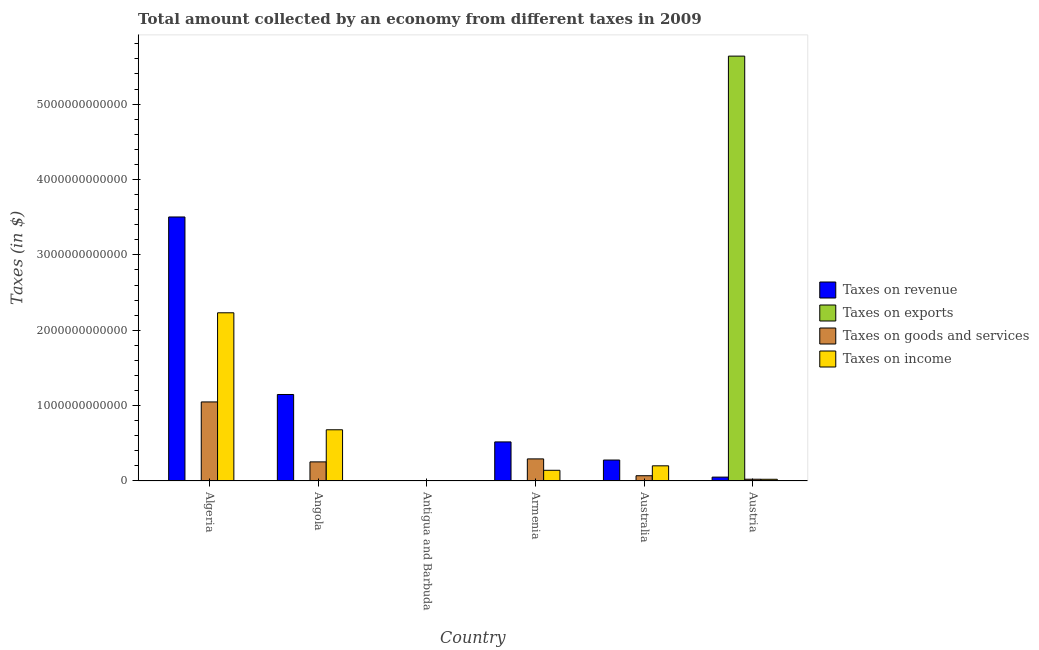How many different coloured bars are there?
Give a very brief answer. 4. How many groups of bars are there?
Offer a terse response. 6. Are the number of bars on each tick of the X-axis equal?
Your response must be concise. Yes. What is the label of the 1st group of bars from the left?
Give a very brief answer. Algeria. What is the amount collected as tax on exports in Algeria?
Your response must be concise. 2.49e+09. Across all countries, what is the maximum amount collected as tax on income?
Ensure brevity in your answer.  2.23e+12. Across all countries, what is the minimum amount collected as tax on goods?
Ensure brevity in your answer.  2.53e+08. In which country was the amount collected as tax on goods maximum?
Offer a very short reply. Algeria. In which country was the amount collected as tax on income minimum?
Your answer should be compact. Antigua and Barbuda. What is the total amount collected as tax on income in the graph?
Give a very brief answer. 3.28e+12. What is the difference between the amount collected as tax on goods in Angola and that in Antigua and Barbuda?
Provide a short and direct response. 2.53e+11. What is the difference between the amount collected as tax on goods in Armenia and the amount collected as tax on exports in Austria?
Your response must be concise. -5.34e+12. What is the average amount collected as tax on income per country?
Your answer should be very brief. 5.46e+11. What is the difference between the amount collected as tax on goods and amount collected as tax on income in Antigua and Barbuda?
Ensure brevity in your answer.  1.55e+08. In how many countries, is the amount collected as tax on exports greater than 4400000000000 $?
Give a very brief answer. 1. What is the ratio of the amount collected as tax on goods in Algeria to that in Australia?
Ensure brevity in your answer.  15. What is the difference between the highest and the second highest amount collected as tax on income?
Make the answer very short. 1.55e+12. What is the difference between the highest and the lowest amount collected as tax on goods?
Provide a short and direct response. 1.05e+12. Is it the case that in every country, the sum of the amount collected as tax on income and amount collected as tax on revenue is greater than the sum of amount collected as tax on exports and amount collected as tax on goods?
Provide a short and direct response. No. What does the 4th bar from the left in Antigua and Barbuda represents?
Provide a short and direct response. Taxes on income. What does the 3rd bar from the right in Algeria represents?
Offer a terse response. Taxes on exports. Is it the case that in every country, the sum of the amount collected as tax on revenue and amount collected as tax on exports is greater than the amount collected as tax on goods?
Make the answer very short. Yes. What is the difference between two consecutive major ticks on the Y-axis?
Your response must be concise. 1.00e+12. Are the values on the major ticks of Y-axis written in scientific E-notation?
Your answer should be compact. No. Does the graph contain any zero values?
Your answer should be compact. No. Does the graph contain grids?
Offer a very short reply. No. How many legend labels are there?
Make the answer very short. 4. How are the legend labels stacked?
Make the answer very short. Vertical. What is the title of the graph?
Give a very brief answer. Total amount collected by an economy from different taxes in 2009. Does "International Monetary Fund" appear as one of the legend labels in the graph?
Your response must be concise. No. What is the label or title of the Y-axis?
Give a very brief answer. Taxes (in $). What is the Taxes (in $) of Taxes on revenue in Algeria?
Your answer should be compact. 3.50e+12. What is the Taxes (in $) in Taxes on exports in Algeria?
Your response must be concise. 2.49e+09. What is the Taxes (in $) in Taxes on goods and services in Algeria?
Provide a short and direct response. 1.05e+12. What is the Taxes (in $) in Taxes on income in Algeria?
Offer a very short reply. 2.23e+12. What is the Taxes (in $) of Taxes on revenue in Angola?
Provide a short and direct response. 1.15e+12. What is the Taxes (in $) in Taxes on exports in Angola?
Ensure brevity in your answer.  7.26e+06. What is the Taxes (in $) of Taxes on goods and services in Angola?
Ensure brevity in your answer.  2.53e+11. What is the Taxes (in $) of Taxes on income in Angola?
Provide a short and direct response. 6.80e+11. What is the Taxes (in $) of Taxes on revenue in Antigua and Barbuda?
Offer a terse response. 5.73e+08. What is the Taxes (in $) in Taxes on exports in Antigua and Barbuda?
Give a very brief answer. 1.30e+07. What is the Taxes (in $) of Taxes on goods and services in Antigua and Barbuda?
Give a very brief answer. 2.53e+08. What is the Taxes (in $) in Taxes on income in Antigua and Barbuda?
Offer a terse response. 9.80e+07. What is the Taxes (in $) of Taxes on revenue in Armenia?
Keep it short and to the point. 5.19e+11. What is the Taxes (in $) in Taxes on exports in Armenia?
Offer a terse response. 2.00e+05. What is the Taxes (in $) of Taxes on goods and services in Armenia?
Offer a terse response. 2.93e+11. What is the Taxes (in $) in Taxes on income in Armenia?
Offer a very short reply. 1.42e+11. What is the Taxes (in $) of Taxes on revenue in Australia?
Keep it short and to the point. 2.78e+11. What is the Taxes (in $) of Taxes on exports in Australia?
Ensure brevity in your answer.  1.27e+07. What is the Taxes (in $) of Taxes on goods and services in Australia?
Keep it short and to the point. 7.00e+1. What is the Taxes (in $) in Taxes on income in Australia?
Offer a terse response. 2.01e+11. What is the Taxes (in $) of Taxes on revenue in Austria?
Your answer should be compact. 5.14e+1. What is the Taxes (in $) in Taxes on exports in Austria?
Offer a terse response. 5.64e+12. What is the Taxes (in $) of Taxes on goods and services in Austria?
Make the answer very short. 2.34e+1. What is the Taxes (in $) of Taxes on income in Austria?
Your answer should be compact. 2.29e+1. Across all countries, what is the maximum Taxes (in $) of Taxes on revenue?
Your answer should be very brief. 3.50e+12. Across all countries, what is the maximum Taxes (in $) of Taxes on exports?
Offer a very short reply. 5.64e+12. Across all countries, what is the maximum Taxes (in $) in Taxes on goods and services?
Make the answer very short. 1.05e+12. Across all countries, what is the maximum Taxes (in $) in Taxes on income?
Offer a very short reply. 2.23e+12. Across all countries, what is the minimum Taxes (in $) in Taxes on revenue?
Keep it short and to the point. 5.73e+08. Across all countries, what is the minimum Taxes (in $) of Taxes on goods and services?
Provide a succinct answer. 2.53e+08. Across all countries, what is the minimum Taxes (in $) in Taxes on income?
Ensure brevity in your answer.  9.80e+07. What is the total Taxes (in $) in Taxes on revenue in the graph?
Keep it short and to the point. 5.50e+12. What is the total Taxes (in $) in Taxes on exports in the graph?
Make the answer very short. 5.64e+12. What is the total Taxes (in $) of Taxes on goods and services in the graph?
Keep it short and to the point. 1.69e+12. What is the total Taxes (in $) of Taxes on income in the graph?
Provide a short and direct response. 3.28e+12. What is the difference between the Taxes (in $) in Taxes on revenue in Algeria and that in Angola?
Ensure brevity in your answer.  2.36e+12. What is the difference between the Taxes (in $) in Taxes on exports in Algeria and that in Angola?
Ensure brevity in your answer.  2.49e+09. What is the difference between the Taxes (in $) in Taxes on goods and services in Algeria and that in Angola?
Provide a short and direct response. 7.95e+11. What is the difference between the Taxes (in $) of Taxes on income in Algeria and that in Angola?
Your response must be concise. 1.55e+12. What is the difference between the Taxes (in $) in Taxes on revenue in Algeria and that in Antigua and Barbuda?
Give a very brief answer. 3.50e+12. What is the difference between the Taxes (in $) in Taxes on exports in Algeria and that in Antigua and Barbuda?
Offer a very short reply. 2.48e+09. What is the difference between the Taxes (in $) of Taxes on goods and services in Algeria and that in Antigua and Barbuda?
Provide a succinct answer. 1.05e+12. What is the difference between the Taxes (in $) in Taxes on income in Algeria and that in Antigua and Barbuda?
Keep it short and to the point. 2.23e+12. What is the difference between the Taxes (in $) in Taxes on revenue in Algeria and that in Armenia?
Your response must be concise. 2.98e+12. What is the difference between the Taxes (in $) of Taxes on exports in Algeria and that in Armenia?
Ensure brevity in your answer.  2.49e+09. What is the difference between the Taxes (in $) of Taxes on goods and services in Algeria and that in Armenia?
Keep it short and to the point. 7.56e+11. What is the difference between the Taxes (in $) in Taxes on income in Algeria and that in Armenia?
Ensure brevity in your answer.  2.09e+12. What is the difference between the Taxes (in $) of Taxes on revenue in Algeria and that in Australia?
Keep it short and to the point. 3.23e+12. What is the difference between the Taxes (in $) in Taxes on exports in Algeria and that in Australia?
Your answer should be compact. 2.48e+09. What is the difference between the Taxes (in $) in Taxes on goods and services in Algeria and that in Australia?
Your answer should be compact. 9.79e+11. What is the difference between the Taxes (in $) of Taxes on income in Algeria and that in Australia?
Your answer should be very brief. 2.03e+12. What is the difference between the Taxes (in $) in Taxes on revenue in Algeria and that in Austria?
Make the answer very short. 3.45e+12. What is the difference between the Taxes (in $) of Taxes on exports in Algeria and that in Austria?
Provide a short and direct response. -5.63e+12. What is the difference between the Taxes (in $) of Taxes on goods and services in Algeria and that in Austria?
Your response must be concise. 1.03e+12. What is the difference between the Taxes (in $) in Taxes on income in Algeria and that in Austria?
Give a very brief answer. 2.21e+12. What is the difference between the Taxes (in $) in Taxes on revenue in Angola and that in Antigua and Barbuda?
Offer a very short reply. 1.15e+12. What is the difference between the Taxes (in $) in Taxes on exports in Angola and that in Antigua and Barbuda?
Your answer should be very brief. -5.74e+06. What is the difference between the Taxes (in $) of Taxes on goods and services in Angola and that in Antigua and Barbuda?
Offer a very short reply. 2.53e+11. What is the difference between the Taxes (in $) in Taxes on income in Angola and that in Antigua and Barbuda?
Your answer should be compact. 6.79e+11. What is the difference between the Taxes (in $) of Taxes on revenue in Angola and that in Armenia?
Ensure brevity in your answer.  6.29e+11. What is the difference between the Taxes (in $) of Taxes on exports in Angola and that in Armenia?
Offer a terse response. 7.06e+06. What is the difference between the Taxes (in $) in Taxes on goods and services in Angola and that in Armenia?
Provide a succinct answer. -3.96e+1. What is the difference between the Taxes (in $) of Taxes on income in Angola and that in Armenia?
Keep it short and to the point. 5.38e+11. What is the difference between the Taxes (in $) of Taxes on revenue in Angola and that in Australia?
Your answer should be compact. 8.70e+11. What is the difference between the Taxes (in $) of Taxes on exports in Angola and that in Australia?
Give a very brief answer. -5.48e+06. What is the difference between the Taxes (in $) of Taxes on goods and services in Angola and that in Australia?
Keep it short and to the point. 1.84e+11. What is the difference between the Taxes (in $) of Taxes on income in Angola and that in Australia?
Provide a short and direct response. 4.78e+11. What is the difference between the Taxes (in $) of Taxes on revenue in Angola and that in Austria?
Your response must be concise. 1.10e+12. What is the difference between the Taxes (in $) of Taxes on exports in Angola and that in Austria?
Ensure brevity in your answer.  -5.64e+12. What is the difference between the Taxes (in $) in Taxes on goods and services in Angola and that in Austria?
Your answer should be very brief. 2.30e+11. What is the difference between the Taxes (in $) of Taxes on income in Angola and that in Austria?
Provide a short and direct response. 6.57e+11. What is the difference between the Taxes (in $) of Taxes on revenue in Antigua and Barbuda and that in Armenia?
Offer a very short reply. -5.18e+11. What is the difference between the Taxes (in $) of Taxes on exports in Antigua and Barbuda and that in Armenia?
Keep it short and to the point. 1.28e+07. What is the difference between the Taxes (in $) of Taxes on goods and services in Antigua and Barbuda and that in Armenia?
Ensure brevity in your answer.  -2.93e+11. What is the difference between the Taxes (in $) in Taxes on income in Antigua and Barbuda and that in Armenia?
Keep it short and to the point. -1.42e+11. What is the difference between the Taxes (in $) of Taxes on revenue in Antigua and Barbuda and that in Australia?
Offer a terse response. -2.77e+11. What is the difference between the Taxes (in $) of Taxes on exports in Antigua and Barbuda and that in Australia?
Provide a succinct answer. 2.55e+05. What is the difference between the Taxes (in $) of Taxes on goods and services in Antigua and Barbuda and that in Australia?
Give a very brief answer. -6.97e+1. What is the difference between the Taxes (in $) of Taxes on income in Antigua and Barbuda and that in Australia?
Provide a short and direct response. -2.01e+11. What is the difference between the Taxes (in $) in Taxes on revenue in Antigua and Barbuda and that in Austria?
Offer a terse response. -5.08e+1. What is the difference between the Taxes (in $) in Taxes on exports in Antigua and Barbuda and that in Austria?
Provide a succinct answer. -5.64e+12. What is the difference between the Taxes (in $) in Taxes on goods and services in Antigua and Barbuda and that in Austria?
Your answer should be compact. -2.32e+1. What is the difference between the Taxes (in $) of Taxes on income in Antigua and Barbuda and that in Austria?
Ensure brevity in your answer.  -2.28e+1. What is the difference between the Taxes (in $) of Taxes on revenue in Armenia and that in Australia?
Keep it short and to the point. 2.41e+11. What is the difference between the Taxes (in $) in Taxes on exports in Armenia and that in Australia?
Give a very brief answer. -1.25e+07. What is the difference between the Taxes (in $) of Taxes on goods and services in Armenia and that in Australia?
Your answer should be very brief. 2.23e+11. What is the difference between the Taxes (in $) in Taxes on income in Armenia and that in Australia?
Offer a very short reply. -5.93e+1. What is the difference between the Taxes (in $) of Taxes on revenue in Armenia and that in Austria?
Offer a very short reply. 4.67e+11. What is the difference between the Taxes (in $) in Taxes on exports in Armenia and that in Austria?
Give a very brief answer. -5.64e+12. What is the difference between the Taxes (in $) of Taxes on goods and services in Armenia and that in Austria?
Give a very brief answer. 2.70e+11. What is the difference between the Taxes (in $) of Taxes on income in Armenia and that in Austria?
Your answer should be compact. 1.19e+11. What is the difference between the Taxes (in $) of Taxes on revenue in Australia and that in Austria?
Your response must be concise. 2.27e+11. What is the difference between the Taxes (in $) in Taxes on exports in Australia and that in Austria?
Your answer should be compact. -5.64e+12. What is the difference between the Taxes (in $) in Taxes on goods and services in Australia and that in Austria?
Provide a short and direct response. 4.65e+1. What is the difference between the Taxes (in $) of Taxes on income in Australia and that in Austria?
Offer a terse response. 1.78e+11. What is the difference between the Taxes (in $) of Taxes on revenue in Algeria and the Taxes (in $) of Taxes on exports in Angola?
Provide a succinct answer. 3.50e+12. What is the difference between the Taxes (in $) in Taxes on revenue in Algeria and the Taxes (in $) in Taxes on goods and services in Angola?
Provide a short and direct response. 3.25e+12. What is the difference between the Taxes (in $) of Taxes on revenue in Algeria and the Taxes (in $) of Taxes on income in Angola?
Your response must be concise. 2.82e+12. What is the difference between the Taxes (in $) of Taxes on exports in Algeria and the Taxes (in $) of Taxes on goods and services in Angola?
Offer a terse response. -2.51e+11. What is the difference between the Taxes (in $) in Taxes on exports in Algeria and the Taxes (in $) in Taxes on income in Angola?
Your answer should be compact. -6.77e+11. What is the difference between the Taxes (in $) in Taxes on goods and services in Algeria and the Taxes (in $) in Taxes on income in Angola?
Your answer should be very brief. 3.69e+11. What is the difference between the Taxes (in $) in Taxes on revenue in Algeria and the Taxes (in $) in Taxes on exports in Antigua and Barbuda?
Make the answer very short. 3.50e+12. What is the difference between the Taxes (in $) in Taxes on revenue in Algeria and the Taxes (in $) in Taxes on goods and services in Antigua and Barbuda?
Offer a terse response. 3.50e+12. What is the difference between the Taxes (in $) of Taxes on revenue in Algeria and the Taxes (in $) of Taxes on income in Antigua and Barbuda?
Make the answer very short. 3.50e+12. What is the difference between the Taxes (in $) of Taxes on exports in Algeria and the Taxes (in $) of Taxes on goods and services in Antigua and Barbuda?
Provide a succinct answer. 2.24e+09. What is the difference between the Taxes (in $) in Taxes on exports in Algeria and the Taxes (in $) in Taxes on income in Antigua and Barbuda?
Offer a very short reply. 2.40e+09. What is the difference between the Taxes (in $) of Taxes on goods and services in Algeria and the Taxes (in $) of Taxes on income in Antigua and Barbuda?
Give a very brief answer. 1.05e+12. What is the difference between the Taxes (in $) in Taxes on revenue in Algeria and the Taxes (in $) in Taxes on exports in Armenia?
Your response must be concise. 3.50e+12. What is the difference between the Taxes (in $) in Taxes on revenue in Algeria and the Taxes (in $) in Taxes on goods and services in Armenia?
Provide a succinct answer. 3.21e+12. What is the difference between the Taxes (in $) in Taxes on revenue in Algeria and the Taxes (in $) in Taxes on income in Armenia?
Provide a short and direct response. 3.36e+12. What is the difference between the Taxes (in $) in Taxes on exports in Algeria and the Taxes (in $) in Taxes on goods and services in Armenia?
Your response must be concise. -2.91e+11. What is the difference between the Taxes (in $) in Taxes on exports in Algeria and the Taxes (in $) in Taxes on income in Armenia?
Offer a terse response. -1.40e+11. What is the difference between the Taxes (in $) in Taxes on goods and services in Algeria and the Taxes (in $) in Taxes on income in Armenia?
Give a very brief answer. 9.07e+11. What is the difference between the Taxes (in $) of Taxes on revenue in Algeria and the Taxes (in $) of Taxes on exports in Australia?
Your answer should be compact. 3.50e+12. What is the difference between the Taxes (in $) in Taxes on revenue in Algeria and the Taxes (in $) in Taxes on goods and services in Australia?
Your answer should be very brief. 3.43e+12. What is the difference between the Taxes (in $) of Taxes on revenue in Algeria and the Taxes (in $) of Taxes on income in Australia?
Give a very brief answer. 3.30e+12. What is the difference between the Taxes (in $) of Taxes on exports in Algeria and the Taxes (in $) of Taxes on goods and services in Australia?
Ensure brevity in your answer.  -6.75e+1. What is the difference between the Taxes (in $) of Taxes on exports in Algeria and the Taxes (in $) of Taxes on income in Australia?
Provide a succinct answer. -1.99e+11. What is the difference between the Taxes (in $) in Taxes on goods and services in Algeria and the Taxes (in $) in Taxes on income in Australia?
Offer a terse response. 8.48e+11. What is the difference between the Taxes (in $) of Taxes on revenue in Algeria and the Taxes (in $) of Taxes on exports in Austria?
Ensure brevity in your answer.  -2.13e+12. What is the difference between the Taxes (in $) in Taxes on revenue in Algeria and the Taxes (in $) in Taxes on goods and services in Austria?
Give a very brief answer. 3.48e+12. What is the difference between the Taxes (in $) of Taxes on revenue in Algeria and the Taxes (in $) of Taxes on income in Austria?
Ensure brevity in your answer.  3.48e+12. What is the difference between the Taxes (in $) of Taxes on exports in Algeria and the Taxes (in $) of Taxes on goods and services in Austria?
Your response must be concise. -2.09e+1. What is the difference between the Taxes (in $) of Taxes on exports in Algeria and the Taxes (in $) of Taxes on income in Austria?
Ensure brevity in your answer.  -2.04e+1. What is the difference between the Taxes (in $) of Taxes on goods and services in Algeria and the Taxes (in $) of Taxes on income in Austria?
Provide a succinct answer. 1.03e+12. What is the difference between the Taxes (in $) in Taxes on revenue in Angola and the Taxes (in $) in Taxes on exports in Antigua and Barbuda?
Your answer should be compact. 1.15e+12. What is the difference between the Taxes (in $) of Taxes on revenue in Angola and the Taxes (in $) of Taxes on goods and services in Antigua and Barbuda?
Make the answer very short. 1.15e+12. What is the difference between the Taxes (in $) of Taxes on revenue in Angola and the Taxes (in $) of Taxes on income in Antigua and Barbuda?
Make the answer very short. 1.15e+12. What is the difference between the Taxes (in $) of Taxes on exports in Angola and the Taxes (in $) of Taxes on goods and services in Antigua and Barbuda?
Provide a short and direct response. -2.45e+08. What is the difference between the Taxes (in $) of Taxes on exports in Angola and the Taxes (in $) of Taxes on income in Antigua and Barbuda?
Ensure brevity in your answer.  -9.07e+07. What is the difference between the Taxes (in $) of Taxes on goods and services in Angola and the Taxes (in $) of Taxes on income in Antigua and Barbuda?
Offer a terse response. 2.53e+11. What is the difference between the Taxes (in $) of Taxes on revenue in Angola and the Taxes (in $) of Taxes on exports in Armenia?
Make the answer very short. 1.15e+12. What is the difference between the Taxes (in $) in Taxes on revenue in Angola and the Taxes (in $) in Taxes on goods and services in Armenia?
Provide a short and direct response. 8.55e+11. What is the difference between the Taxes (in $) in Taxes on revenue in Angola and the Taxes (in $) in Taxes on income in Armenia?
Provide a short and direct response. 1.01e+12. What is the difference between the Taxes (in $) of Taxes on exports in Angola and the Taxes (in $) of Taxes on goods and services in Armenia?
Provide a short and direct response. -2.93e+11. What is the difference between the Taxes (in $) in Taxes on exports in Angola and the Taxes (in $) in Taxes on income in Armenia?
Your response must be concise. -1.42e+11. What is the difference between the Taxes (in $) of Taxes on goods and services in Angola and the Taxes (in $) of Taxes on income in Armenia?
Ensure brevity in your answer.  1.11e+11. What is the difference between the Taxes (in $) of Taxes on revenue in Angola and the Taxes (in $) of Taxes on exports in Australia?
Your response must be concise. 1.15e+12. What is the difference between the Taxes (in $) in Taxes on revenue in Angola and the Taxes (in $) in Taxes on goods and services in Australia?
Your answer should be very brief. 1.08e+12. What is the difference between the Taxes (in $) in Taxes on revenue in Angola and the Taxes (in $) in Taxes on income in Australia?
Your response must be concise. 9.46e+11. What is the difference between the Taxes (in $) in Taxes on exports in Angola and the Taxes (in $) in Taxes on goods and services in Australia?
Provide a succinct answer. -6.99e+1. What is the difference between the Taxes (in $) in Taxes on exports in Angola and the Taxes (in $) in Taxes on income in Australia?
Your response must be concise. -2.01e+11. What is the difference between the Taxes (in $) of Taxes on goods and services in Angola and the Taxes (in $) of Taxes on income in Australia?
Ensure brevity in your answer.  5.21e+1. What is the difference between the Taxes (in $) of Taxes on revenue in Angola and the Taxes (in $) of Taxes on exports in Austria?
Provide a short and direct response. -4.49e+12. What is the difference between the Taxes (in $) in Taxes on revenue in Angola and the Taxes (in $) in Taxes on goods and services in Austria?
Your answer should be compact. 1.12e+12. What is the difference between the Taxes (in $) of Taxes on revenue in Angola and the Taxes (in $) of Taxes on income in Austria?
Offer a terse response. 1.12e+12. What is the difference between the Taxes (in $) of Taxes on exports in Angola and the Taxes (in $) of Taxes on goods and services in Austria?
Give a very brief answer. -2.34e+1. What is the difference between the Taxes (in $) in Taxes on exports in Angola and the Taxes (in $) in Taxes on income in Austria?
Your response must be concise. -2.29e+1. What is the difference between the Taxes (in $) in Taxes on goods and services in Angola and the Taxes (in $) in Taxes on income in Austria?
Ensure brevity in your answer.  2.31e+11. What is the difference between the Taxes (in $) of Taxes on revenue in Antigua and Barbuda and the Taxes (in $) of Taxes on exports in Armenia?
Give a very brief answer. 5.73e+08. What is the difference between the Taxes (in $) in Taxes on revenue in Antigua and Barbuda and the Taxes (in $) in Taxes on goods and services in Armenia?
Offer a terse response. -2.93e+11. What is the difference between the Taxes (in $) of Taxes on revenue in Antigua and Barbuda and the Taxes (in $) of Taxes on income in Armenia?
Provide a short and direct response. -1.41e+11. What is the difference between the Taxes (in $) in Taxes on exports in Antigua and Barbuda and the Taxes (in $) in Taxes on goods and services in Armenia?
Offer a terse response. -2.93e+11. What is the difference between the Taxes (in $) in Taxes on exports in Antigua and Barbuda and the Taxes (in $) in Taxes on income in Armenia?
Offer a very short reply. -1.42e+11. What is the difference between the Taxes (in $) of Taxes on goods and services in Antigua and Barbuda and the Taxes (in $) of Taxes on income in Armenia?
Keep it short and to the point. -1.42e+11. What is the difference between the Taxes (in $) of Taxes on revenue in Antigua and Barbuda and the Taxes (in $) of Taxes on exports in Australia?
Provide a succinct answer. 5.61e+08. What is the difference between the Taxes (in $) in Taxes on revenue in Antigua and Barbuda and the Taxes (in $) in Taxes on goods and services in Australia?
Your answer should be very brief. -6.94e+1. What is the difference between the Taxes (in $) in Taxes on revenue in Antigua and Barbuda and the Taxes (in $) in Taxes on income in Australia?
Your answer should be very brief. -2.01e+11. What is the difference between the Taxes (in $) of Taxes on exports in Antigua and Barbuda and the Taxes (in $) of Taxes on goods and services in Australia?
Your response must be concise. -6.99e+1. What is the difference between the Taxes (in $) in Taxes on exports in Antigua and Barbuda and the Taxes (in $) in Taxes on income in Australia?
Ensure brevity in your answer.  -2.01e+11. What is the difference between the Taxes (in $) in Taxes on goods and services in Antigua and Barbuda and the Taxes (in $) in Taxes on income in Australia?
Provide a succinct answer. -2.01e+11. What is the difference between the Taxes (in $) in Taxes on revenue in Antigua and Barbuda and the Taxes (in $) in Taxes on exports in Austria?
Your answer should be compact. -5.64e+12. What is the difference between the Taxes (in $) of Taxes on revenue in Antigua and Barbuda and the Taxes (in $) of Taxes on goods and services in Austria?
Your answer should be very brief. -2.28e+1. What is the difference between the Taxes (in $) of Taxes on revenue in Antigua and Barbuda and the Taxes (in $) of Taxes on income in Austria?
Give a very brief answer. -2.23e+1. What is the difference between the Taxes (in $) in Taxes on exports in Antigua and Barbuda and the Taxes (in $) in Taxes on goods and services in Austria?
Your response must be concise. -2.34e+1. What is the difference between the Taxes (in $) in Taxes on exports in Antigua and Barbuda and the Taxes (in $) in Taxes on income in Austria?
Your answer should be compact. -2.29e+1. What is the difference between the Taxes (in $) of Taxes on goods and services in Antigua and Barbuda and the Taxes (in $) of Taxes on income in Austria?
Make the answer very short. -2.27e+1. What is the difference between the Taxes (in $) of Taxes on revenue in Armenia and the Taxes (in $) of Taxes on exports in Australia?
Keep it short and to the point. 5.19e+11. What is the difference between the Taxes (in $) in Taxes on revenue in Armenia and the Taxes (in $) in Taxes on goods and services in Australia?
Give a very brief answer. 4.49e+11. What is the difference between the Taxes (in $) of Taxes on revenue in Armenia and the Taxes (in $) of Taxes on income in Australia?
Your answer should be very brief. 3.17e+11. What is the difference between the Taxes (in $) in Taxes on exports in Armenia and the Taxes (in $) in Taxes on goods and services in Australia?
Give a very brief answer. -7.00e+1. What is the difference between the Taxes (in $) in Taxes on exports in Armenia and the Taxes (in $) in Taxes on income in Australia?
Give a very brief answer. -2.01e+11. What is the difference between the Taxes (in $) in Taxes on goods and services in Armenia and the Taxes (in $) in Taxes on income in Australia?
Offer a very short reply. 9.18e+1. What is the difference between the Taxes (in $) in Taxes on revenue in Armenia and the Taxes (in $) in Taxes on exports in Austria?
Keep it short and to the point. -5.12e+12. What is the difference between the Taxes (in $) of Taxes on revenue in Armenia and the Taxes (in $) of Taxes on goods and services in Austria?
Provide a short and direct response. 4.95e+11. What is the difference between the Taxes (in $) of Taxes on revenue in Armenia and the Taxes (in $) of Taxes on income in Austria?
Ensure brevity in your answer.  4.96e+11. What is the difference between the Taxes (in $) of Taxes on exports in Armenia and the Taxes (in $) of Taxes on goods and services in Austria?
Your answer should be compact. -2.34e+1. What is the difference between the Taxes (in $) in Taxes on exports in Armenia and the Taxes (in $) in Taxes on income in Austria?
Provide a succinct answer. -2.29e+1. What is the difference between the Taxes (in $) in Taxes on goods and services in Armenia and the Taxes (in $) in Taxes on income in Austria?
Ensure brevity in your answer.  2.70e+11. What is the difference between the Taxes (in $) in Taxes on revenue in Australia and the Taxes (in $) in Taxes on exports in Austria?
Your answer should be compact. -5.36e+12. What is the difference between the Taxes (in $) in Taxes on revenue in Australia and the Taxes (in $) in Taxes on goods and services in Austria?
Provide a short and direct response. 2.55e+11. What is the difference between the Taxes (in $) in Taxes on revenue in Australia and the Taxes (in $) in Taxes on income in Austria?
Offer a very short reply. 2.55e+11. What is the difference between the Taxes (in $) of Taxes on exports in Australia and the Taxes (in $) of Taxes on goods and services in Austria?
Your answer should be very brief. -2.34e+1. What is the difference between the Taxes (in $) of Taxes on exports in Australia and the Taxes (in $) of Taxes on income in Austria?
Your response must be concise. -2.29e+1. What is the difference between the Taxes (in $) of Taxes on goods and services in Australia and the Taxes (in $) of Taxes on income in Austria?
Ensure brevity in your answer.  4.70e+1. What is the average Taxes (in $) in Taxes on revenue per country?
Your response must be concise. 9.17e+11. What is the average Taxes (in $) of Taxes on exports per country?
Offer a terse response. 9.40e+11. What is the average Taxes (in $) in Taxes on goods and services per country?
Keep it short and to the point. 2.82e+11. What is the average Taxes (in $) of Taxes on income per country?
Your response must be concise. 5.46e+11. What is the difference between the Taxes (in $) in Taxes on revenue and Taxes (in $) in Taxes on exports in Algeria?
Provide a short and direct response. 3.50e+12. What is the difference between the Taxes (in $) in Taxes on revenue and Taxes (in $) in Taxes on goods and services in Algeria?
Give a very brief answer. 2.45e+12. What is the difference between the Taxes (in $) of Taxes on revenue and Taxes (in $) of Taxes on income in Algeria?
Provide a short and direct response. 1.27e+12. What is the difference between the Taxes (in $) of Taxes on exports and Taxes (in $) of Taxes on goods and services in Algeria?
Ensure brevity in your answer.  -1.05e+12. What is the difference between the Taxes (in $) in Taxes on exports and Taxes (in $) in Taxes on income in Algeria?
Provide a short and direct response. -2.23e+12. What is the difference between the Taxes (in $) of Taxes on goods and services and Taxes (in $) of Taxes on income in Algeria?
Your response must be concise. -1.18e+12. What is the difference between the Taxes (in $) of Taxes on revenue and Taxes (in $) of Taxes on exports in Angola?
Make the answer very short. 1.15e+12. What is the difference between the Taxes (in $) of Taxes on revenue and Taxes (in $) of Taxes on goods and services in Angola?
Offer a terse response. 8.94e+11. What is the difference between the Taxes (in $) of Taxes on revenue and Taxes (in $) of Taxes on income in Angola?
Offer a very short reply. 4.68e+11. What is the difference between the Taxes (in $) in Taxes on exports and Taxes (in $) in Taxes on goods and services in Angola?
Your response must be concise. -2.53e+11. What is the difference between the Taxes (in $) of Taxes on exports and Taxes (in $) of Taxes on income in Angola?
Offer a very short reply. -6.80e+11. What is the difference between the Taxes (in $) of Taxes on goods and services and Taxes (in $) of Taxes on income in Angola?
Provide a succinct answer. -4.26e+11. What is the difference between the Taxes (in $) in Taxes on revenue and Taxes (in $) in Taxes on exports in Antigua and Barbuda?
Give a very brief answer. 5.60e+08. What is the difference between the Taxes (in $) in Taxes on revenue and Taxes (in $) in Taxes on goods and services in Antigua and Barbuda?
Provide a succinct answer. 3.21e+08. What is the difference between the Taxes (in $) in Taxes on revenue and Taxes (in $) in Taxes on income in Antigua and Barbuda?
Give a very brief answer. 4.75e+08. What is the difference between the Taxes (in $) in Taxes on exports and Taxes (in $) in Taxes on goods and services in Antigua and Barbuda?
Provide a succinct answer. -2.40e+08. What is the difference between the Taxes (in $) in Taxes on exports and Taxes (in $) in Taxes on income in Antigua and Barbuda?
Your answer should be very brief. -8.50e+07. What is the difference between the Taxes (in $) in Taxes on goods and services and Taxes (in $) in Taxes on income in Antigua and Barbuda?
Your response must be concise. 1.55e+08. What is the difference between the Taxes (in $) in Taxes on revenue and Taxes (in $) in Taxes on exports in Armenia?
Offer a terse response. 5.19e+11. What is the difference between the Taxes (in $) of Taxes on revenue and Taxes (in $) of Taxes on goods and services in Armenia?
Provide a short and direct response. 2.25e+11. What is the difference between the Taxes (in $) in Taxes on revenue and Taxes (in $) in Taxes on income in Armenia?
Your response must be concise. 3.77e+11. What is the difference between the Taxes (in $) of Taxes on exports and Taxes (in $) of Taxes on goods and services in Armenia?
Make the answer very short. -2.93e+11. What is the difference between the Taxes (in $) in Taxes on exports and Taxes (in $) in Taxes on income in Armenia?
Your answer should be very brief. -1.42e+11. What is the difference between the Taxes (in $) in Taxes on goods and services and Taxes (in $) in Taxes on income in Armenia?
Keep it short and to the point. 1.51e+11. What is the difference between the Taxes (in $) in Taxes on revenue and Taxes (in $) in Taxes on exports in Australia?
Make the answer very short. 2.78e+11. What is the difference between the Taxes (in $) of Taxes on revenue and Taxes (in $) of Taxes on goods and services in Australia?
Offer a terse response. 2.08e+11. What is the difference between the Taxes (in $) in Taxes on revenue and Taxes (in $) in Taxes on income in Australia?
Your answer should be very brief. 7.66e+1. What is the difference between the Taxes (in $) of Taxes on exports and Taxes (in $) of Taxes on goods and services in Australia?
Offer a very short reply. -6.99e+1. What is the difference between the Taxes (in $) in Taxes on exports and Taxes (in $) in Taxes on income in Australia?
Ensure brevity in your answer.  -2.01e+11. What is the difference between the Taxes (in $) in Taxes on goods and services and Taxes (in $) in Taxes on income in Australia?
Your response must be concise. -1.31e+11. What is the difference between the Taxes (in $) in Taxes on revenue and Taxes (in $) in Taxes on exports in Austria?
Your answer should be compact. -5.59e+12. What is the difference between the Taxes (in $) of Taxes on revenue and Taxes (in $) of Taxes on goods and services in Austria?
Provide a succinct answer. 2.79e+1. What is the difference between the Taxes (in $) of Taxes on revenue and Taxes (in $) of Taxes on income in Austria?
Keep it short and to the point. 2.84e+1. What is the difference between the Taxes (in $) of Taxes on exports and Taxes (in $) of Taxes on goods and services in Austria?
Provide a succinct answer. 5.61e+12. What is the difference between the Taxes (in $) in Taxes on exports and Taxes (in $) in Taxes on income in Austria?
Your answer should be compact. 5.61e+12. What is the difference between the Taxes (in $) in Taxes on goods and services and Taxes (in $) in Taxes on income in Austria?
Offer a terse response. 5.01e+08. What is the ratio of the Taxes (in $) of Taxes on revenue in Algeria to that in Angola?
Your answer should be very brief. 3.05. What is the ratio of the Taxes (in $) in Taxes on exports in Algeria to that in Angola?
Your answer should be very brief. 343.47. What is the ratio of the Taxes (in $) in Taxes on goods and services in Algeria to that in Angola?
Provide a short and direct response. 4.14. What is the ratio of the Taxes (in $) of Taxes on income in Algeria to that in Angola?
Offer a very short reply. 3.28. What is the ratio of the Taxes (in $) of Taxes on revenue in Algeria to that in Antigua and Barbuda?
Your answer should be compact. 6109.27. What is the ratio of the Taxes (in $) in Taxes on exports in Algeria to that in Antigua and Barbuda?
Provide a succinct answer. 191.82. What is the ratio of the Taxes (in $) of Taxes on goods and services in Algeria to that in Antigua and Barbuda?
Give a very brief answer. 4152.56. What is the ratio of the Taxes (in $) of Taxes on income in Algeria to that in Antigua and Barbuda?
Your answer should be very brief. 2.28e+04. What is the ratio of the Taxes (in $) in Taxes on revenue in Algeria to that in Armenia?
Make the answer very short. 6.76. What is the ratio of the Taxes (in $) of Taxes on exports in Algeria to that in Armenia?
Provide a short and direct response. 1.25e+04. What is the ratio of the Taxes (in $) of Taxes on goods and services in Algeria to that in Armenia?
Give a very brief answer. 3.58. What is the ratio of the Taxes (in $) of Taxes on income in Algeria to that in Armenia?
Your response must be concise. 15.71. What is the ratio of the Taxes (in $) of Taxes on revenue in Algeria to that in Australia?
Give a very brief answer. 12.6. What is the ratio of the Taxes (in $) in Taxes on exports in Algeria to that in Australia?
Offer a terse response. 195.66. What is the ratio of the Taxes (in $) in Taxes on goods and services in Algeria to that in Australia?
Provide a succinct answer. 15. What is the ratio of the Taxes (in $) of Taxes on income in Algeria to that in Australia?
Keep it short and to the point. 11.08. What is the ratio of the Taxes (in $) in Taxes on revenue in Algeria to that in Austria?
Provide a short and direct response. 68.21. What is the ratio of the Taxes (in $) in Taxes on exports in Algeria to that in Austria?
Give a very brief answer. 0. What is the ratio of the Taxes (in $) in Taxes on goods and services in Algeria to that in Austria?
Give a very brief answer. 44.79. What is the ratio of the Taxes (in $) of Taxes on income in Algeria to that in Austria?
Your response must be concise. 97.38. What is the ratio of the Taxes (in $) in Taxes on revenue in Angola to that in Antigua and Barbuda?
Give a very brief answer. 2001.72. What is the ratio of the Taxes (in $) in Taxes on exports in Angola to that in Antigua and Barbuda?
Give a very brief answer. 0.56. What is the ratio of the Taxes (in $) of Taxes on goods and services in Angola to that in Antigua and Barbuda?
Offer a terse response. 1003.56. What is the ratio of the Taxes (in $) of Taxes on income in Angola to that in Antigua and Barbuda?
Make the answer very short. 6934.55. What is the ratio of the Taxes (in $) of Taxes on revenue in Angola to that in Armenia?
Provide a short and direct response. 2.21. What is the ratio of the Taxes (in $) of Taxes on exports in Angola to that in Armenia?
Provide a short and direct response. 36.3. What is the ratio of the Taxes (in $) in Taxes on goods and services in Angola to that in Armenia?
Offer a terse response. 0.86. What is the ratio of the Taxes (in $) in Taxes on income in Angola to that in Armenia?
Provide a succinct answer. 4.79. What is the ratio of the Taxes (in $) in Taxes on revenue in Angola to that in Australia?
Provide a short and direct response. 4.13. What is the ratio of the Taxes (in $) of Taxes on exports in Angola to that in Australia?
Give a very brief answer. 0.57. What is the ratio of the Taxes (in $) of Taxes on goods and services in Angola to that in Australia?
Your answer should be very brief. 3.62. What is the ratio of the Taxes (in $) of Taxes on income in Angola to that in Australia?
Provide a succinct answer. 3.37. What is the ratio of the Taxes (in $) in Taxes on revenue in Angola to that in Austria?
Keep it short and to the point. 22.35. What is the ratio of the Taxes (in $) of Taxes on goods and services in Angola to that in Austria?
Offer a very short reply. 10.82. What is the ratio of the Taxes (in $) of Taxes on income in Angola to that in Austria?
Offer a very short reply. 29.65. What is the ratio of the Taxes (in $) of Taxes on revenue in Antigua and Barbuda to that in Armenia?
Ensure brevity in your answer.  0. What is the ratio of the Taxes (in $) in Taxes on goods and services in Antigua and Barbuda to that in Armenia?
Provide a succinct answer. 0. What is the ratio of the Taxes (in $) in Taxes on income in Antigua and Barbuda to that in Armenia?
Your answer should be compact. 0. What is the ratio of the Taxes (in $) of Taxes on revenue in Antigua and Barbuda to that in Australia?
Provide a short and direct response. 0. What is the ratio of the Taxes (in $) in Taxes on goods and services in Antigua and Barbuda to that in Australia?
Keep it short and to the point. 0. What is the ratio of the Taxes (in $) of Taxes on income in Antigua and Barbuda to that in Australia?
Keep it short and to the point. 0. What is the ratio of the Taxes (in $) of Taxes on revenue in Antigua and Barbuda to that in Austria?
Ensure brevity in your answer.  0.01. What is the ratio of the Taxes (in $) in Taxes on goods and services in Antigua and Barbuda to that in Austria?
Make the answer very short. 0.01. What is the ratio of the Taxes (in $) of Taxes on income in Antigua and Barbuda to that in Austria?
Your answer should be compact. 0. What is the ratio of the Taxes (in $) in Taxes on revenue in Armenia to that in Australia?
Your answer should be compact. 1.87. What is the ratio of the Taxes (in $) in Taxes on exports in Armenia to that in Australia?
Offer a terse response. 0.02. What is the ratio of the Taxes (in $) of Taxes on goods and services in Armenia to that in Australia?
Your answer should be compact. 4.19. What is the ratio of the Taxes (in $) of Taxes on income in Armenia to that in Australia?
Keep it short and to the point. 0.71. What is the ratio of the Taxes (in $) in Taxes on revenue in Armenia to that in Austria?
Offer a terse response. 10.1. What is the ratio of the Taxes (in $) of Taxes on exports in Armenia to that in Austria?
Provide a succinct answer. 0. What is the ratio of the Taxes (in $) of Taxes on goods and services in Armenia to that in Austria?
Ensure brevity in your answer.  12.52. What is the ratio of the Taxes (in $) in Taxes on income in Armenia to that in Austria?
Make the answer very short. 6.2. What is the ratio of the Taxes (in $) in Taxes on revenue in Australia to that in Austria?
Make the answer very short. 5.41. What is the ratio of the Taxes (in $) in Taxes on goods and services in Australia to that in Austria?
Ensure brevity in your answer.  2.99. What is the ratio of the Taxes (in $) of Taxes on income in Australia to that in Austria?
Offer a terse response. 8.79. What is the difference between the highest and the second highest Taxes (in $) in Taxes on revenue?
Give a very brief answer. 2.36e+12. What is the difference between the highest and the second highest Taxes (in $) in Taxes on exports?
Give a very brief answer. 5.63e+12. What is the difference between the highest and the second highest Taxes (in $) of Taxes on goods and services?
Ensure brevity in your answer.  7.56e+11. What is the difference between the highest and the second highest Taxes (in $) of Taxes on income?
Your answer should be compact. 1.55e+12. What is the difference between the highest and the lowest Taxes (in $) of Taxes on revenue?
Offer a very short reply. 3.50e+12. What is the difference between the highest and the lowest Taxes (in $) of Taxes on exports?
Offer a terse response. 5.64e+12. What is the difference between the highest and the lowest Taxes (in $) in Taxes on goods and services?
Keep it short and to the point. 1.05e+12. What is the difference between the highest and the lowest Taxes (in $) of Taxes on income?
Your answer should be compact. 2.23e+12. 